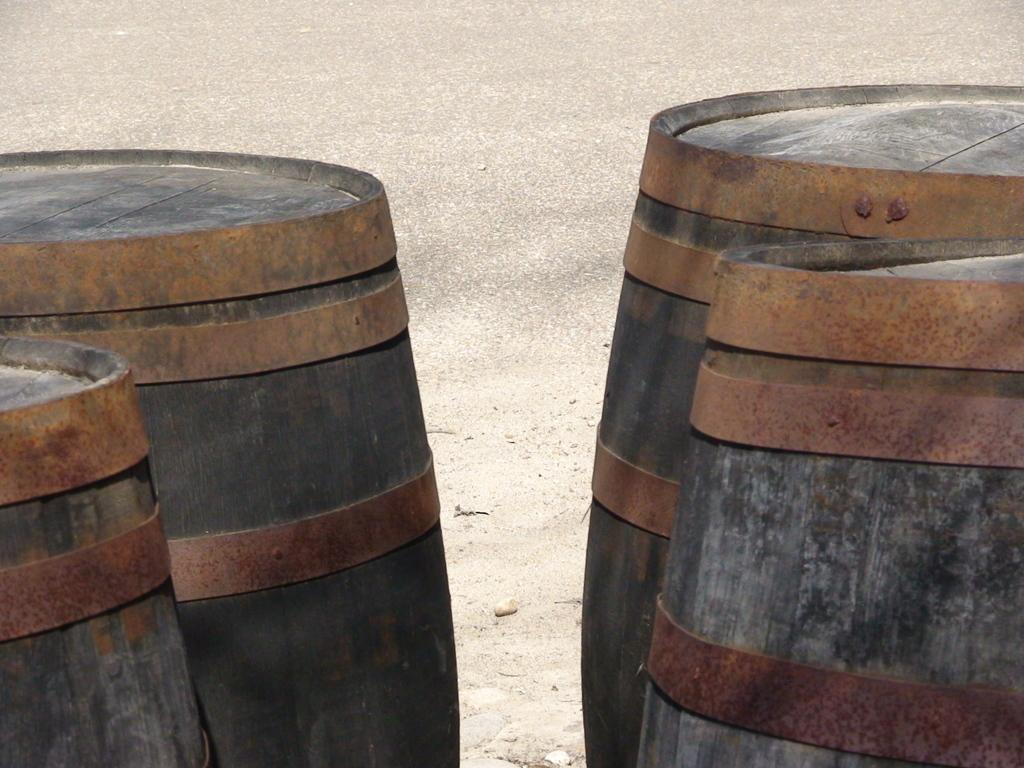What objects are present in the image? There are barrels in the image. What type of hope can be seen growing in the barrels in the image? There is no mention of hope or any type of plant in the image; it only features barrels. 